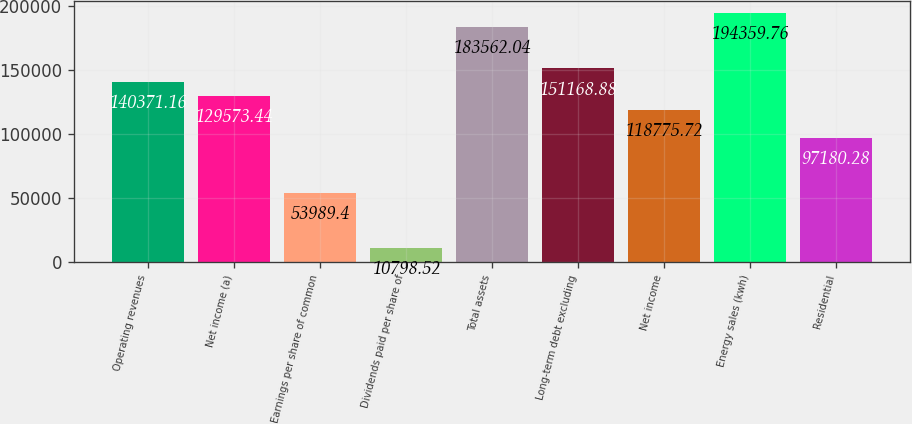Convert chart to OTSL. <chart><loc_0><loc_0><loc_500><loc_500><bar_chart><fcel>Operating revenues<fcel>Net income (a)<fcel>Earnings per share of common<fcel>Dividends paid per share of<fcel>Total assets<fcel>Long-term debt excluding<fcel>Net income<fcel>Energy sales (kwh)<fcel>Residential<nl><fcel>140371<fcel>129573<fcel>53989.4<fcel>10798.5<fcel>183562<fcel>151169<fcel>118776<fcel>194360<fcel>97180.3<nl></chart> 